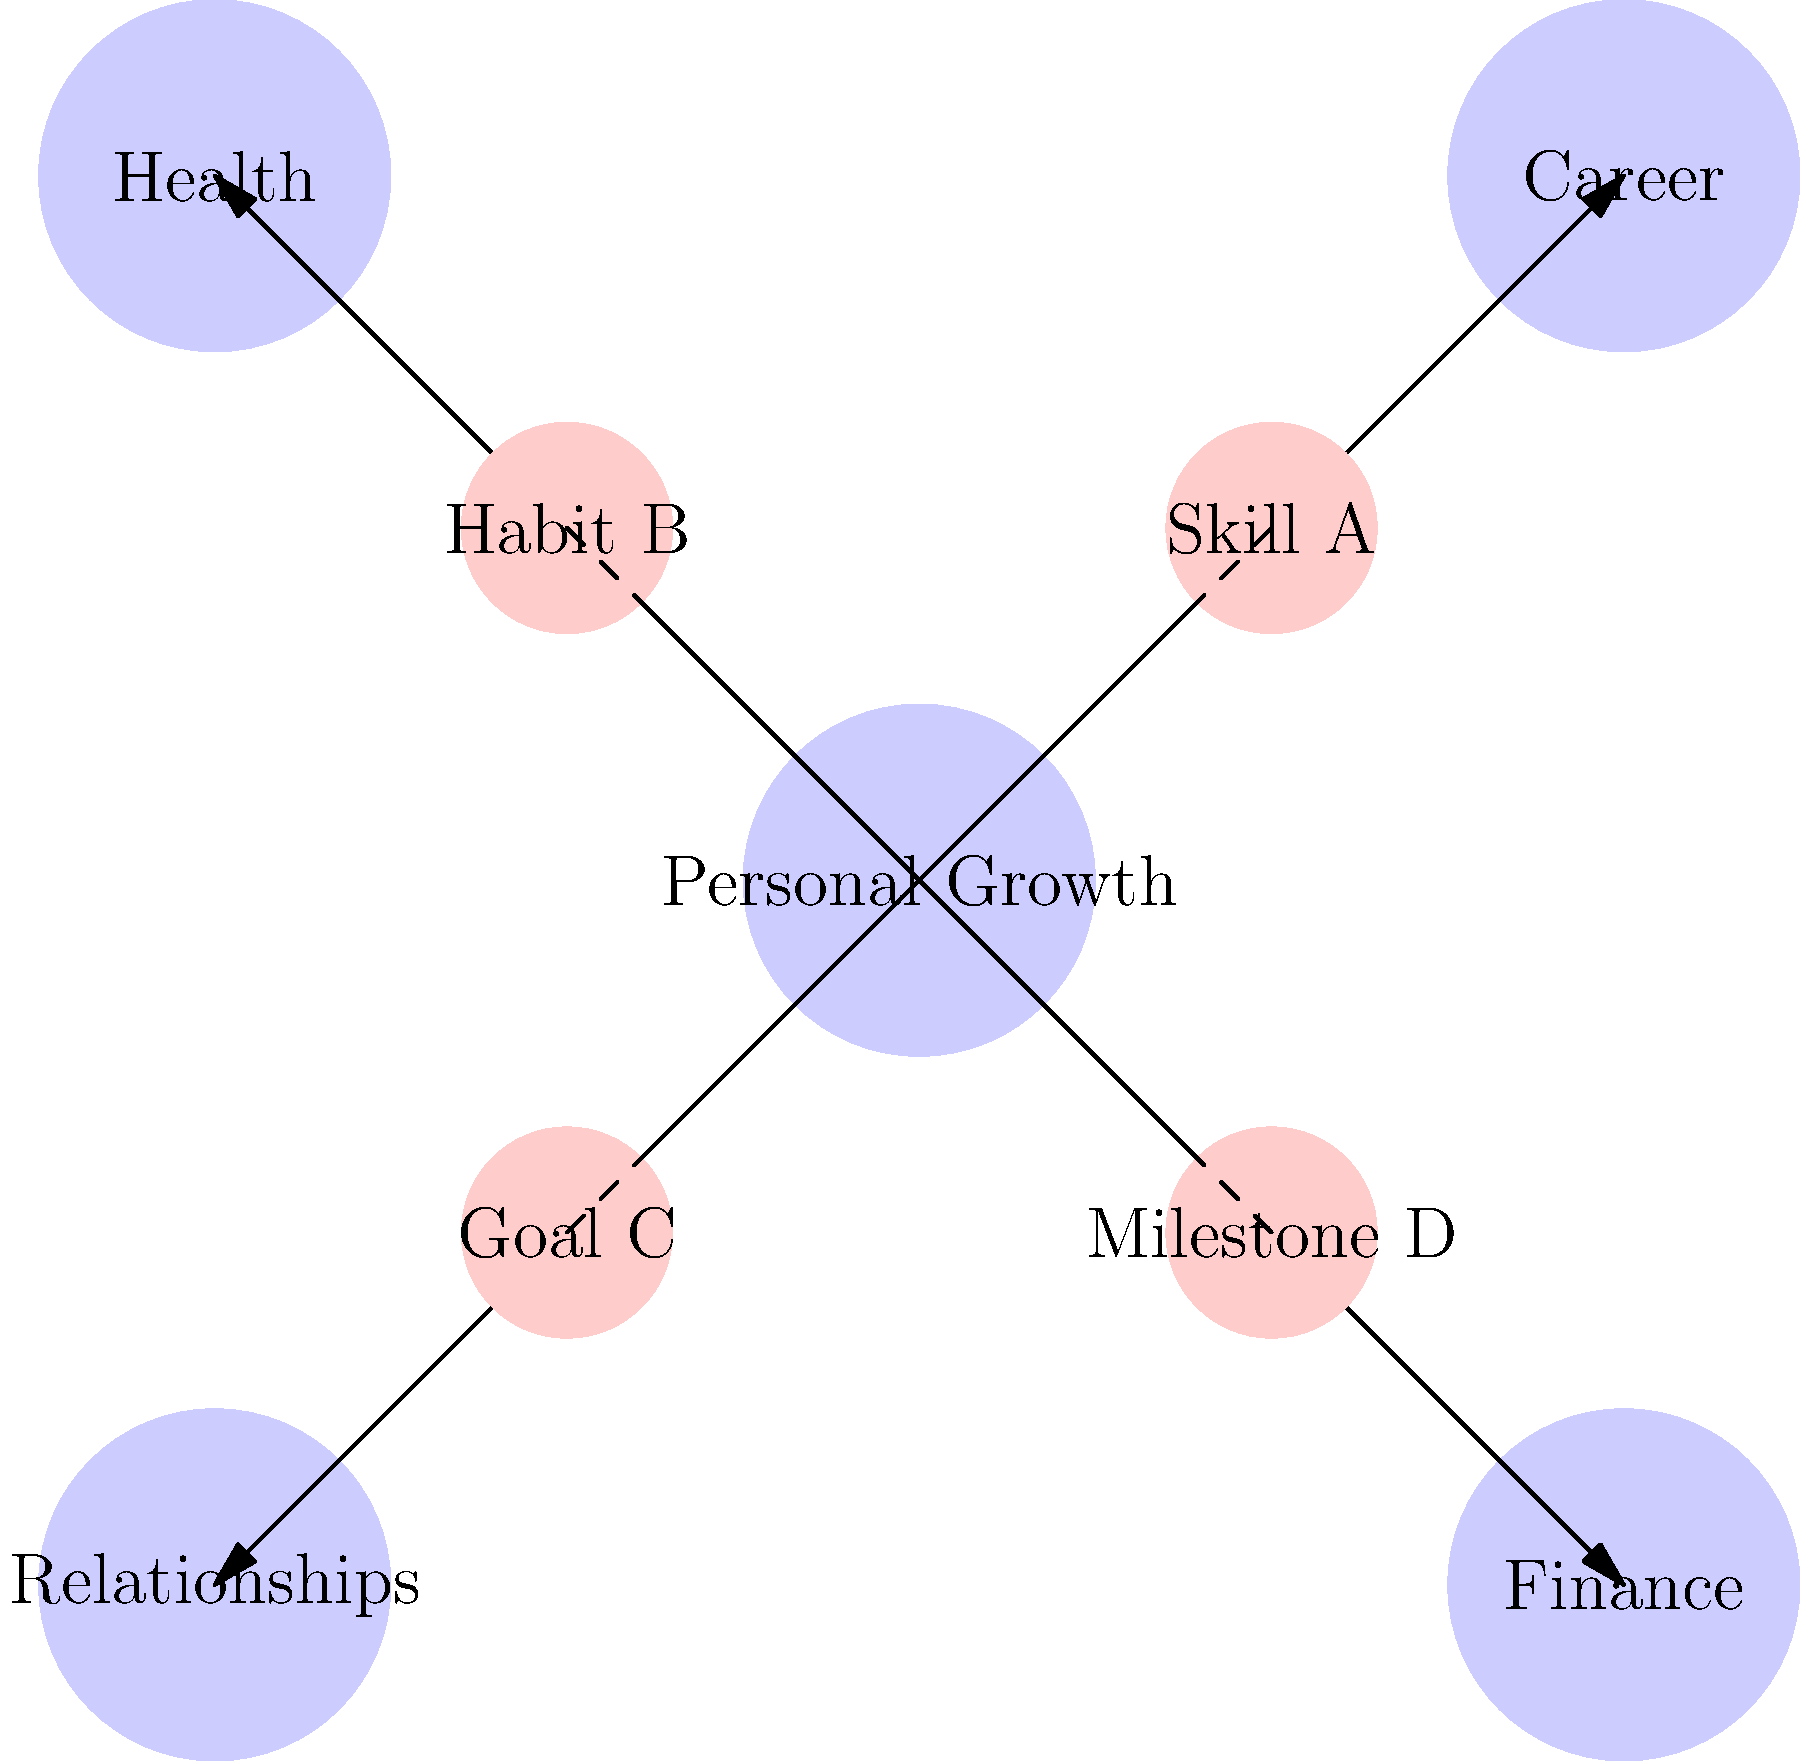In this personal growth mindmap, how many direct connections does the central "Personal Growth" node have to other main areas and subgoals combined? To solve this spatial reasoning task, we need to carefully examine the mindmap and count the connections:

1. First, let's count the main areas connected to "Personal Growth":
   - Career
   - Health
   - Relationships
   - Finance
   Total main areas: 4

2. Now, let's count the subgoals directly connected to "Personal Growth":
   - Skill A
   - Habit B
   - Goal C
   - Milestone D
   Total subgoals: 4

3. To find the total number of direct connections, we add the connections to main areas and subgoals:
   $4 \text{ (main areas)} + 4 \text{ (subgoals)} = 8 \text{ total connections}$

Therefore, the central "Personal Growth" node has 8 direct connections to other main areas and subgoals combined.
Answer: 8 